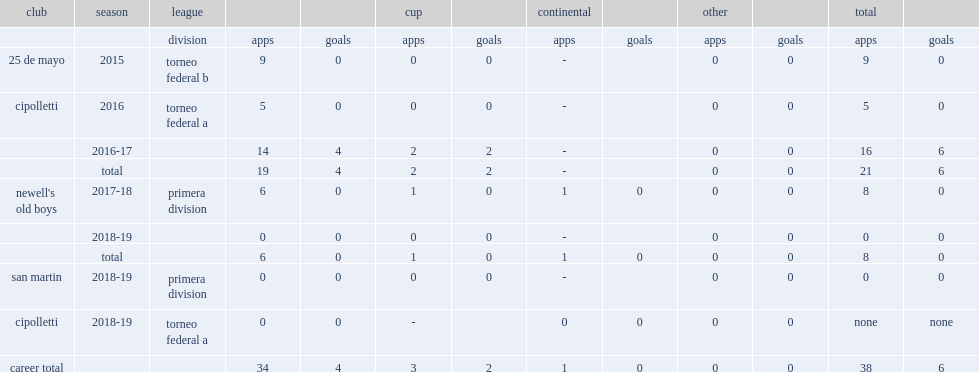Which club did opazo play for in 2016? Cipolletti. 